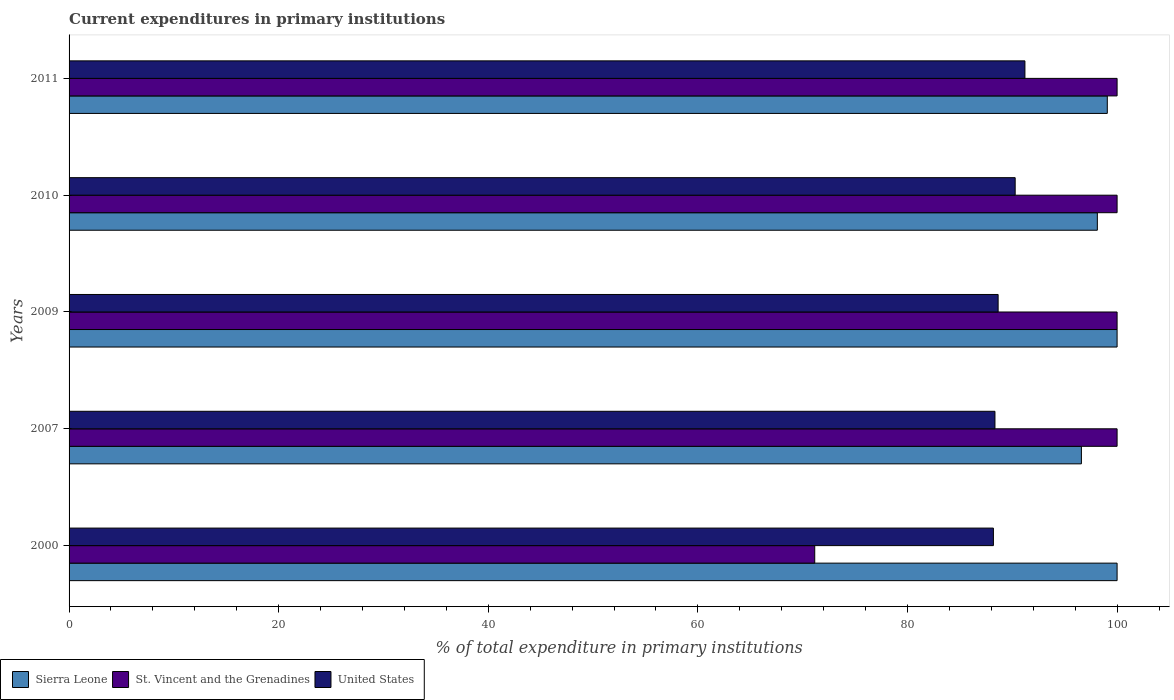How many different coloured bars are there?
Offer a terse response. 3. How many bars are there on the 4th tick from the bottom?
Offer a very short reply. 3. What is the current expenditures in primary institutions in Sierra Leone in 2011?
Provide a short and direct response. 99.07. Across all years, what is the maximum current expenditures in primary institutions in St. Vincent and the Grenadines?
Your response must be concise. 100. Across all years, what is the minimum current expenditures in primary institutions in United States?
Make the answer very short. 88.2. In which year was the current expenditures in primary institutions in St. Vincent and the Grenadines minimum?
Give a very brief answer. 2000. What is the total current expenditures in primary institutions in Sierra Leone in the graph?
Make the answer very short. 493.78. What is the difference between the current expenditures in primary institutions in St. Vincent and the Grenadines in 2007 and that in 2011?
Your answer should be compact. 0. What is the difference between the current expenditures in primary institutions in Sierra Leone in 2010 and the current expenditures in primary institutions in St. Vincent and the Grenadines in 2000?
Your answer should be very brief. 26.97. What is the average current expenditures in primary institutions in Sierra Leone per year?
Your answer should be compact. 98.76. In the year 2010, what is the difference between the current expenditures in primary institutions in St. Vincent and the Grenadines and current expenditures in primary institutions in United States?
Provide a short and direct response. 9.73. What is the ratio of the current expenditures in primary institutions in United States in 2009 to that in 2010?
Your answer should be very brief. 0.98. Is the current expenditures in primary institutions in United States in 2010 less than that in 2011?
Keep it short and to the point. Yes. Is the difference between the current expenditures in primary institutions in St. Vincent and the Grenadines in 2000 and 2007 greater than the difference between the current expenditures in primary institutions in United States in 2000 and 2007?
Keep it short and to the point. No. What is the difference between the highest and the second highest current expenditures in primary institutions in United States?
Give a very brief answer. 0.93. What is the difference between the highest and the lowest current expenditures in primary institutions in St. Vincent and the Grenadines?
Provide a short and direct response. 28.85. In how many years, is the current expenditures in primary institutions in St. Vincent and the Grenadines greater than the average current expenditures in primary institutions in St. Vincent and the Grenadines taken over all years?
Offer a terse response. 4. Is the sum of the current expenditures in primary institutions in St. Vincent and the Grenadines in 2000 and 2010 greater than the maximum current expenditures in primary institutions in Sierra Leone across all years?
Your response must be concise. Yes. What does the 2nd bar from the top in 2009 represents?
Offer a terse response. St. Vincent and the Grenadines. What does the 2nd bar from the bottom in 2000 represents?
Your answer should be very brief. St. Vincent and the Grenadines. Is it the case that in every year, the sum of the current expenditures in primary institutions in United States and current expenditures in primary institutions in St. Vincent and the Grenadines is greater than the current expenditures in primary institutions in Sierra Leone?
Offer a very short reply. Yes. How many bars are there?
Offer a terse response. 15. How many years are there in the graph?
Offer a very short reply. 5. Does the graph contain grids?
Keep it short and to the point. No. How many legend labels are there?
Keep it short and to the point. 3. How are the legend labels stacked?
Your answer should be compact. Horizontal. What is the title of the graph?
Your response must be concise. Current expenditures in primary institutions. What is the label or title of the X-axis?
Ensure brevity in your answer.  % of total expenditure in primary institutions. What is the label or title of the Y-axis?
Make the answer very short. Years. What is the % of total expenditure in primary institutions in St. Vincent and the Grenadines in 2000?
Your answer should be very brief. 71.15. What is the % of total expenditure in primary institutions of United States in 2000?
Offer a very short reply. 88.2. What is the % of total expenditure in primary institutions of Sierra Leone in 2007?
Provide a short and direct response. 96.6. What is the % of total expenditure in primary institutions of United States in 2007?
Provide a succinct answer. 88.35. What is the % of total expenditure in primary institutions in Sierra Leone in 2009?
Offer a terse response. 100. What is the % of total expenditure in primary institutions in United States in 2009?
Offer a terse response. 88.65. What is the % of total expenditure in primary institutions in Sierra Leone in 2010?
Offer a terse response. 98.12. What is the % of total expenditure in primary institutions in United States in 2010?
Your answer should be compact. 90.27. What is the % of total expenditure in primary institutions of Sierra Leone in 2011?
Provide a short and direct response. 99.07. What is the % of total expenditure in primary institutions in St. Vincent and the Grenadines in 2011?
Your response must be concise. 100. What is the % of total expenditure in primary institutions in United States in 2011?
Provide a succinct answer. 91.21. Across all years, what is the maximum % of total expenditure in primary institutions of Sierra Leone?
Offer a very short reply. 100. Across all years, what is the maximum % of total expenditure in primary institutions of St. Vincent and the Grenadines?
Your response must be concise. 100. Across all years, what is the maximum % of total expenditure in primary institutions of United States?
Offer a terse response. 91.21. Across all years, what is the minimum % of total expenditure in primary institutions of Sierra Leone?
Provide a succinct answer. 96.6. Across all years, what is the minimum % of total expenditure in primary institutions in St. Vincent and the Grenadines?
Ensure brevity in your answer.  71.15. Across all years, what is the minimum % of total expenditure in primary institutions in United States?
Offer a terse response. 88.2. What is the total % of total expenditure in primary institutions in Sierra Leone in the graph?
Ensure brevity in your answer.  493.78. What is the total % of total expenditure in primary institutions in St. Vincent and the Grenadines in the graph?
Your response must be concise. 471.15. What is the total % of total expenditure in primary institutions of United States in the graph?
Provide a short and direct response. 446.67. What is the difference between the % of total expenditure in primary institutions of Sierra Leone in 2000 and that in 2007?
Offer a terse response. 3.4. What is the difference between the % of total expenditure in primary institutions of St. Vincent and the Grenadines in 2000 and that in 2007?
Ensure brevity in your answer.  -28.85. What is the difference between the % of total expenditure in primary institutions in United States in 2000 and that in 2007?
Ensure brevity in your answer.  -0.15. What is the difference between the % of total expenditure in primary institutions in St. Vincent and the Grenadines in 2000 and that in 2009?
Provide a succinct answer. -28.85. What is the difference between the % of total expenditure in primary institutions of United States in 2000 and that in 2009?
Make the answer very short. -0.45. What is the difference between the % of total expenditure in primary institutions in Sierra Leone in 2000 and that in 2010?
Your answer should be compact. 1.88. What is the difference between the % of total expenditure in primary institutions of St. Vincent and the Grenadines in 2000 and that in 2010?
Offer a very short reply. -28.85. What is the difference between the % of total expenditure in primary institutions of United States in 2000 and that in 2010?
Offer a terse response. -2.08. What is the difference between the % of total expenditure in primary institutions of Sierra Leone in 2000 and that in 2011?
Give a very brief answer. 0.93. What is the difference between the % of total expenditure in primary institutions in St. Vincent and the Grenadines in 2000 and that in 2011?
Keep it short and to the point. -28.85. What is the difference between the % of total expenditure in primary institutions in United States in 2000 and that in 2011?
Your answer should be compact. -3.01. What is the difference between the % of total expenditure in primary institutions in Sierra Leone in 2007 and that in 2009?
Ensure brevity in your answer.  -3.4. What is the difference between the % of total expenditure in primary institutions in St. Vincent and the Grenadines in 2007 and that in 2009?
Provide a short and direct response. 0. What is the difference between the % of total expenditure in primary institutions of United States in 2007 and that in 2009?
Give a very brief answer. -0.3. What is the difference between the % of total expenditure in primary institutions in Sierra Leone in 2007 and that in 2010?
Offer a terse response. -1.52. What is the difference between the % of total expenditure in primary institutions of St. Vincent and the Grenadines in 2007 and that in 2010?
Your answer should be very brief. 0. What is the difference between the % of total expenditure in primary institutions of United States in 2007 and that in 2010?
Your response must be concise. -1.93. What is the difference between the % of total expenditure in primary institutions in Sierra Leone in 2007 and that in 2011?
Your response must be concise. -2.47. What is the difference between the % of total expenditure in primary institutions of United States in 2007 and that in 2011?
Your response must be concise. -2.86. What is the difference between the % of total expenditure in primary institutions in Sierra Leone in 2009 and that in 2010?
Offer a terse response. 1.88. What is the difference between the % of total expenditure in primary institutions in United States in 2009 and that in 2010?
Your response must be concise. -1.63. What is the difference between the % of total expenditure in primary institutions of Sierra Leone in 2009 and that in 2011?
Offer a very short reply. 0.93. What is the difference between the % of total expenditure in primary institutions in United States in 2009 and that in 2011?
Your answer should be compact. -2.56. What is the difference between the % of total expenditure in primary institutions of Sierra Leone in 2010 and that in 2011?
Keep it short and to the point. -0.95. What is the difference between the % of total expenditure in primary institutions in United States in 2010 and that in 2011?
Provide a succinct answer. -0.93. What is the difference between the % of total expenditure in primary institutions of Sierra Leone in 2000 and the % of total expenditure in primary institutions of St. Vincent and the Grenadines in 2007?
Your response must be concise. 0. What is the difference between the % of total expenditure in primary institutions in Sierra Leone in 2000 and the % of total expenditure in primary institutions in United States in 2007?
Your response must be concise. 11.65. What is the difference between the % of total expenditure in primary institutions in St. Vincent and the Grenadines in 2000 and the % of total expenditure in primary institutions in United States in 2007?
Ensure brevity in your answer.  -17.2. What is the difference between the % of total expenditure in primary institutions in Sierra Leone in 2000 and the % of total expenditure in primary institutions in United States in 2009?
Your answer should be very brief. 11.35. What is the difference between the % of total expenditure in primary institutions in St. Vincent and the Grenadines in 2000 and the % of total expenditure in primary institutions in United States in 2009?
Give a very brief answer. -17.5. What is the difference between the % of total expenditure in primary institutions in Sierra Leone in 2000 and the % of total expenditure in primary institutions in United States in 2010?
Ensure brevity in your answer.  9.73. What is the difference between the % of total expenditure in primary institutions of St. Vincent and the Grenadines in 2000 and the % of total expenditure in primary institutions of United States in 2010?
Your response must be concise. -19.12. What is the difference between the % of total expenditure in primary institutions of Sierra Leone in 2000 and the % of total expenditure in primary institutions of United States in 2011?
Your answer should be very brief. 8.79. What is the difference between the % of total expenditure in primary institutions of St. Vincent and the Grenadines in 2000 and the % of total expenditure in primary institutions of United States in 2011?
Your answer should be compact. -20.06. What is the difference between the % of total expenditure in primary institutions in Sierra Leone in 2007 and the % of total expenditure in primary institutions in St. Vincent and the Grenadines in 2009?
Provide a succinct answer. -3.4. What is the difference between the % of total expenditure in primary institutions in Sierra Leone in 2007 and the % of total expenditure in primary institutions in United States in 2009?
Your response must be concise. 7.95. What is the difference between the % of total expenditure in primary institutions of St. Vincent and the Grenadines in 2007 and the % of total expenditure in primary institutions of United States in 2009?
Your answer should be compact. 11.35. What is the difference between the % of total expenditure in primary institutions of Sierra Leone in 2007 and the % of total expenditure in primary institutions of St. Vincent and the Grenadines in 2010?
Give a very brief answer. -3.4. What is the difference between the % of total expenditure in primary institutions in Sierra Leone in 2007 and the % of total expenditure in primary institutions in United States in 2010?
Give a very brief answer. 6.32. What is the difference between the % of total expenditure in primary institutions in St. Vincent and the Grenadines in 2007 and the % of total expenditure in primary institutions in United States in 2010?
Your response must be concise. 9.73. What is the difference between the % of total expenditure in primary institutions of Sierra Leone in 2007 and the % of total expenditure in primary institutions of St. Vincent and the Grenadines in 2011?
Offer a very short reply. -3.4. What is the difference between the % of total expenditure in primary institutions of Sierra Leone in 2007 and the % of total expenditure in primary institutions of United States in 2011?
Your answer should be very brief. 5.39. What is the difference between the % of total expenditure in primary institutions of St. Vincent and the Grenadines in 2007 and the % of total expenditure in primary institutions of United States in 2011?
Your response must be concise. 8.79. What is the difference between the % of total expenditure in primary institutions of Sierra Leone in 2009 and the % of total expenditure in primary institutions of St. Vincent and the Grenadines in 2010?
Your answer should be very brief. 0. What is the difference between the % of total expenditure in primary institutions in Sierra Leone in 2009 and the % of total expenditure in primary institutions in United States in 2010?
Ensure brevity in your answer.  9.73. What is the difference between the % of total expenditure in primary institutions of St. Vincent and the Grenadines in 2009 and the % of total expenditure in primary institutions of United States in 2010?
Provide a short and direct response. 9.73. What is the difference between the % of total expenditure in primary institutions in Sierra Leone in 2009 and the % of total expenditure in primary institutions in St. Vincent and the Grenadines in 2011?
Ensure brevity in your answer.  0. What is the difference between the % of total expenditure in primary institutions in Sierra Leone in 2009 and the % of total expenditure in primary institutions in United States in 2011?
Your answer should be very brief. 8.79. What is the difference between the % of total expenditure in primary institutions of St. Vincent and the Grenadines in 2009 and the % of total expenditure in primary institutions of United States in 2011?
Offer a terse response. 8.79. What is the difference between the % of total expenditure in primary institutions of Sierra Leone in 2010 and the % of total expenditure in primary institutions of St. Vincent and the Grenadines in 2011?
Your answer should be compact. -1.88. What is the difference between the % of total expenditure in primary institutions in Sierra Leone in 2010 and the % of total expenditure in primary institutions in United States in 2011?
Your answer should be compact. 6.91. What is the difference between the % of total expenditure in primary institutions of St. Vincent and the Grenadines in 2010 and the % of total expenditure in primary institutions of United States in 2011?
Keep it short and to the point. 8.79. What is the average % of total expenditure in primary institutions of Sierra Leone per year?
Provide a succinct answer. 98.76. What is the average % of total expenditure in primary institutions of St. Vincent and the Grenadines per year?
Provide a succinct answer. 94.23. What is the average % of total expenditure in primary institutions of United States per year?
Give a very brief answer. 89.33. In the year 2000, what is the difference between the % of total expenditure in primary institutions of Sierra Leone and % of total expenditure in primary institutions of St. Vincent and the Grenadines?
Your response must be concise. 28.85. In the year 2000, what is the difference between the % of total expenditure in primary institutions in Sierra Leone and % of total expenditure in primary institutions in United States?
Your answer should be compact. 11.8. In the year 2000, what is the difference between the % of total expenditure in primary institutions in St. Vincent and the Grenadines and % of total expenditure in primary institutions in United States?
Offer a very short reply. -17.05. In the year 2007, what is the difference between the % of total expenditure in primary institutions of Sierra Leone and % of total expenditure in primary institutions of St. Vincent and the Grenadines?
Offer a terse response. -3.4. In the year 2007, what is the difference between the % of total expenditure in primary institutions in Sierra Leone and % of total expenditure in primary institutions in United States?
Provide a succinct answer. 8.25. In the year 2007, what is the difference between the % of total expenditure in primary institutions in St. Vincent and the Grenadines and % of total expenditure in primary institutions in United States?
Provide a succinct answer. 11.65. In the year 2009, what is the difference between the % of total expenditure in primary institutions of Sierra Leone and % of total expenditure in primary institutions of United States?
Keep it short and to the point. 11.35. In the year 2009, what is the difference between the % of total expenditure in primary institutions of St. Vincent and the Grenadines and % of total expenditure in primary institutions of United States?
Ensure brevity in your answer.  11.35. In the year 2010, what is the difference between the % of total expenditure in primary institutions of Sierra Leone and % of total expenditure in primary institutions of St. Vincent and the Grenadines?
Offer a very short reply. -1.88. In the year 2010, what is the difference between the % of total expenditure in primary institutions in Sierra Leone and % of total expenditure in primary institutions in United States?
Give a very brief answer. 7.84. In the year 2010, what is the difference between the % of total expenditure in primary institutions of St. Vincent and the Grenadines and % of total expenditure in primary institutions of United States?
Offer a terse response. 9.73. In the year 2011, what is the difference between the % of total expenditure in primary institutions of Sierra Leone and % of total expenditure in primary institutions of St. Vincent and the Grenadines?
Make the answer very short. -0.93. In the year 2011, what is the difference between the % of total expenditure in primary institutions of Sierra Leone and % of total expenditure in primary institutions of United States?
Provide a succinct answer. 7.86. In the year 2011, what is the difference between the % of total expenditure in primary institutions of St. Vincent and the Grenadines and % of total expenditure in primary institutions of United States?
Provide a short and direct response. 8.79. What is the ratio of the % of total expenditure in primary institutions in Sierra Leone in 2000 to that in 2007?
Make the answer very short. 1.04. What is the ratio of the % of total expenditure in primary institutions of St. Vincent and the Grenadines in 2000 to that in 2007?
Give a very brief answer. 0.71. What is the ratio of the % of total expenditure in primary institutions in United States in 2000 to that in 2007?
Give a very brief answer. 1. What is the ratio of the % of total expenditure in primary institutions of St. Vincent and the Grenadines in 2000 to that in 2009?
Ensure brevity in your answer.  0.71. What is the ratio of the % of total expenditure in primary institutions of Sierra Leone in 2000 to that in 2010?
Provide a short and direct response. 1.02. What is the ratio of the % of total expenditure in primary institutions of St. Vincent and the Grenadines in 2000 to that in 2010?
Provide a succinct answer. 0.71. What is the ratio of the % of total expenditure in primary institutions of United States in 2000 to that in 2010?
Offer a very short reply. 0.98. What is the ratio of the % of total expenditure in primary institutions of Sierra Leone in 2000 to that in 2011?
Your answer should be very brief. 1.01. What is the ratio of the % of total expenditure in primary institutions of St. Vincent and the Grenadines in 2000 to that in 2011?
Your response must be concise. 0.71. What is the ratio of the % of total expenditure in primary institutions in United States in 2007 to that in 2009?
Make the answer very short. 1. What is the ratio of the % of total expenditure in primary institutions of Sierra Leone in 2007 to that in 2010?
Offer a very short reply. 0.98. What is the ratio of the % of total expenditure in primary institutions of United States in 2007 to that in 2010?
Your response must be concise. 0.98. What is the ratio of the % of total expenditure in primary institutions of Sierra Leone in 2007 to that in 2011?
Provide a short and direct response. 0.98. What is the ratio of the % of total expenditure in primary institutions of United States in 2007 to that in 2011?
Keep it short and to the point. 0.97. What is the ratio of the % of total expenditure in primary institutions in Sierra Leone in 2009 to that in 2010?
Ensure brevity in your answer.  1.02. What is the ratio of the % of total expenditure in primary institutions of Sierra Leone in 2009 to that in 2011?
Offer a terse response. 1.01. What is the ratio of the % of total expenditure in primary institutions in St. Vincent and the Grenadines in 2009 to that in 2011?
Provide a succinct answer. 1. What is the ratio of the % of total expenditure in primary institutions of Sierra Leone in 2010 to that in 2011?
Ensure brevity in your answer.  0.99. What is the difference between the highest and the second highest % of total expenditure in primary institutions of Sierra Leone?
Offer a terse response. 0. What is the difference between the highest and the second highest % of total expenditure in primary institutions of United States?
Your answer should be compact. 0.93. What is the difference between the highest and the lowest % of total expenditure in primary institutions in Sierra Leone?
Your answer should be very brief. 3.4. What is the difference between the highest and the lowest % of total expenditure in primary institutions in St. Vincent and the Grenadines?
Make the answer very short. 28.85. What is the difference between the highest and the lowest % of total expenditure in primary institutions of United States?
Offer a very short reply. 3.01. 